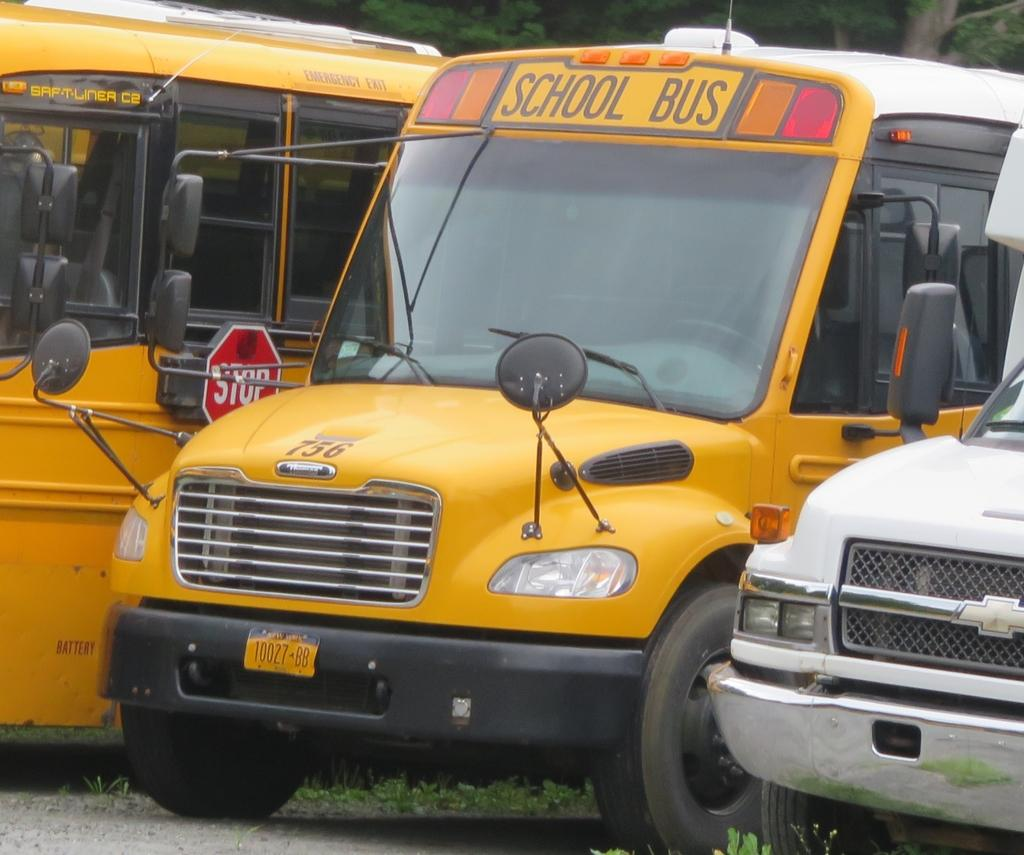What types of objects are on the ground in the image? There are vehicles on the ground in the image. What can be seen in the distance in the image? There are trees visible in the background of the image. What type of board can be seen hanging from the trees in the image? There is no board hanging from the trees in the image; only vehicles on the ground and trees in the background are present. 